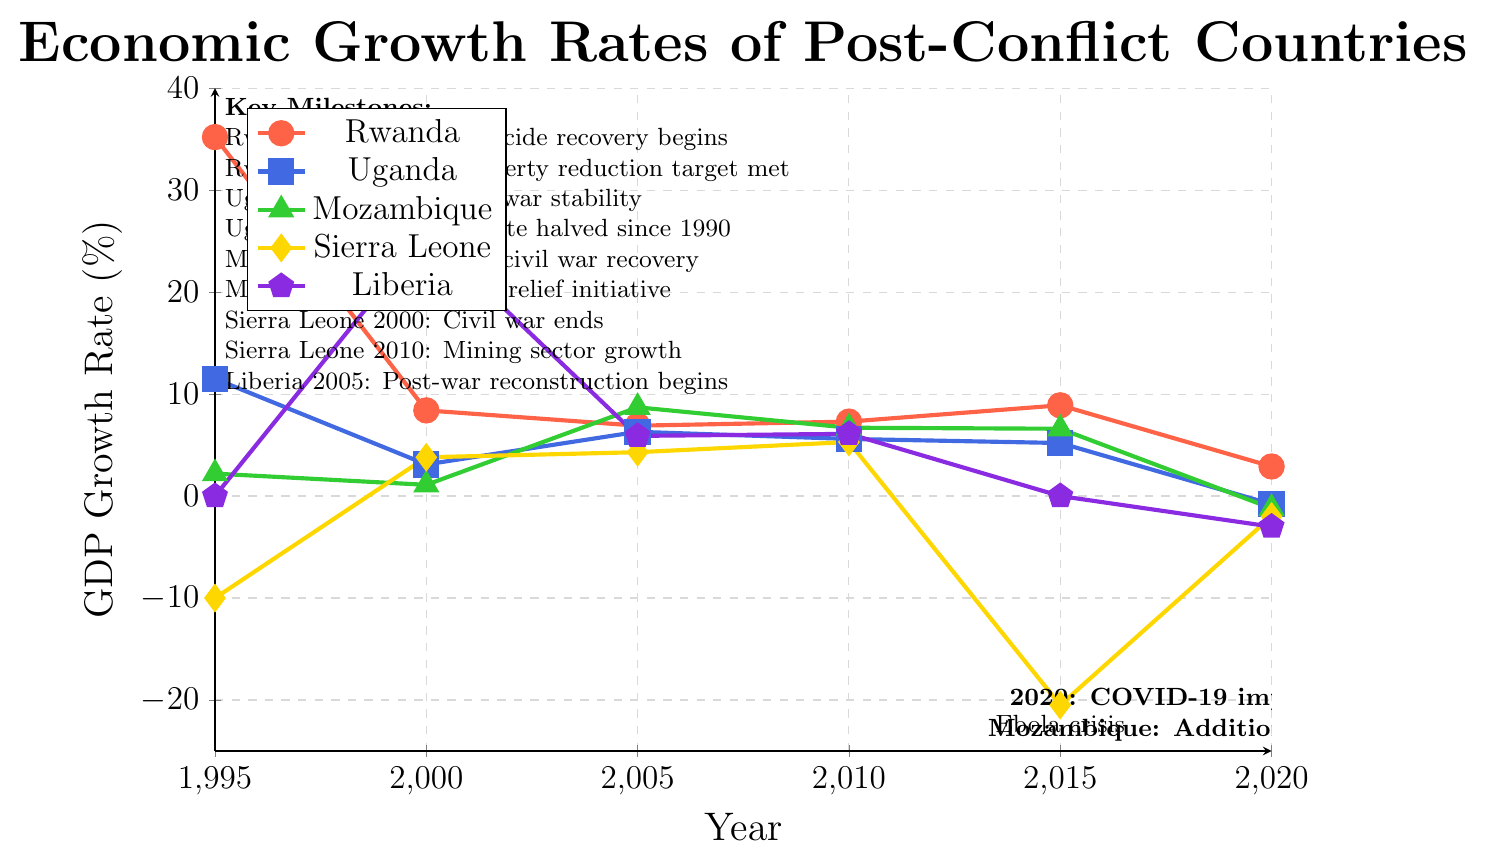What event marked the beginning of Rwanda's economic recovery in 1995? The plot indicates that 1995 was a significant year for Rwanda, with a high GDP growth rate of 35.2%. A milestone noted in the figure for that year is "Post-genocide recovery begins." This milestone marks the start of Rwanda's economic recovery.
Answer: Post-genocide recovery begins Compare the GDP growth rates of Rwanda and Uganda in 2020. Which country had a higher growth rate? The figure shows that in 2020, Rwanda had a GDP growth rate of 2.9%, while Uganda had a GDP growth rate of -0.8%. Comparing these two values, Rwanda had a higher growth rate than Uganda in 2020.
Answer: Rwanda Which country experienced a GDP growth rate of 25.7% in the year 2000? The plot shows different GDP growth rates for various countries in the year 2000. Liberia is indicated to have a remarkably high GDP growth rate of 25.7% for that year, associated with a brief period of peace.
Answer: Liberia What was the impact of the COVID-19 pandemic on Uganda's GDP growth rate in 2020? The chart shows that Uganda's GDP growth rate in 2020 was -0.8%, which is noted as being impacted by COVID-19. This indicates a negative growth rate due to the pandemic.
Answer: -0.8% Identify the GDP growth rate of Sierra Leone in 2015 and the reason for the observed value. The figure indicates that Sierra Leone had a GDP growth rate of -20.5% in 2015, which is a significant downturn. The milestone given for this year is the Ebola crisis, which negatively impacted the economy.
Answer: -20.5%, Ebola crisis Compare the highest GDP growth rates achieved by Rwanda and Mozambique over the 20-year period shown. What are these rates? Rwanda's highest GDP growth rate is shown as 35.2% in 1995, while Mozambique's highest GDP growth rate is 8.7% in 2005. Comparatively, Rwanda's peak growth rate is much higher than Mozambique's.
Answer: Rwanda: 35.2%, Mozambique: 8.7% Calculate the average GDP growth rate of Rwanda from 1995 to 2005. To find the average, we sum the GDP growth rates of Rwanda for 1995 (35.2%), 2000 (8.4%), 2005 (6.9%), and then divide by the number of data points. (35.2 + 8.4 + 6.9) / 3 = 50.5 / 3 = 16.83%
Answer: 16.83% What key milestone did Uganda achieve in 2005 concerning poverty? According to the chart, Uganda achieved a significant milestone in 2005 where the poverty rate was halved since 1990.
Answer: Poverty rate halved since 1990 How did Mozambique’s GDP growth rate change from 2015 to 2020, and what were the reasons for the change? From the chart, Mozambique's GDP growth rate decreased from 6.6% in 2015 to -1.2% in 2020. The drop is noted to be impacted by COVID-19 and an additional insurgency.
Answer: Decreased from 6.6% to -1.2%, COVID-19 and insurgency impact 